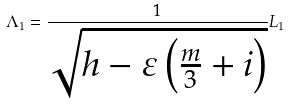<formula> <loc_0><loc_0><loc_500><loc_500>\Lambda _ { 1 } = \frac { 1 } { \sqrt { h - \varepsilon \left ( \frac { m } { 3 } + i \right ) } } L _ { 1 }</formula> 